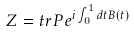<formula> <loc_0><loc_0><loc_500><loc_500>Z = t r P e ^ { i \int _ { 0 } ^ { 1 } d t B ( t ) }</formula> 